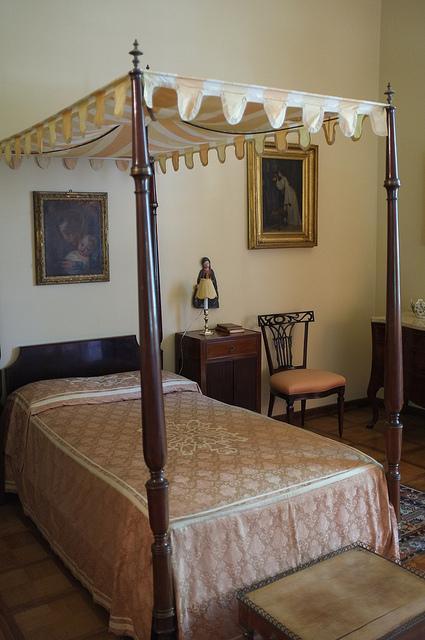How many paintings on the wall?
Give a very brief answer. 2. 